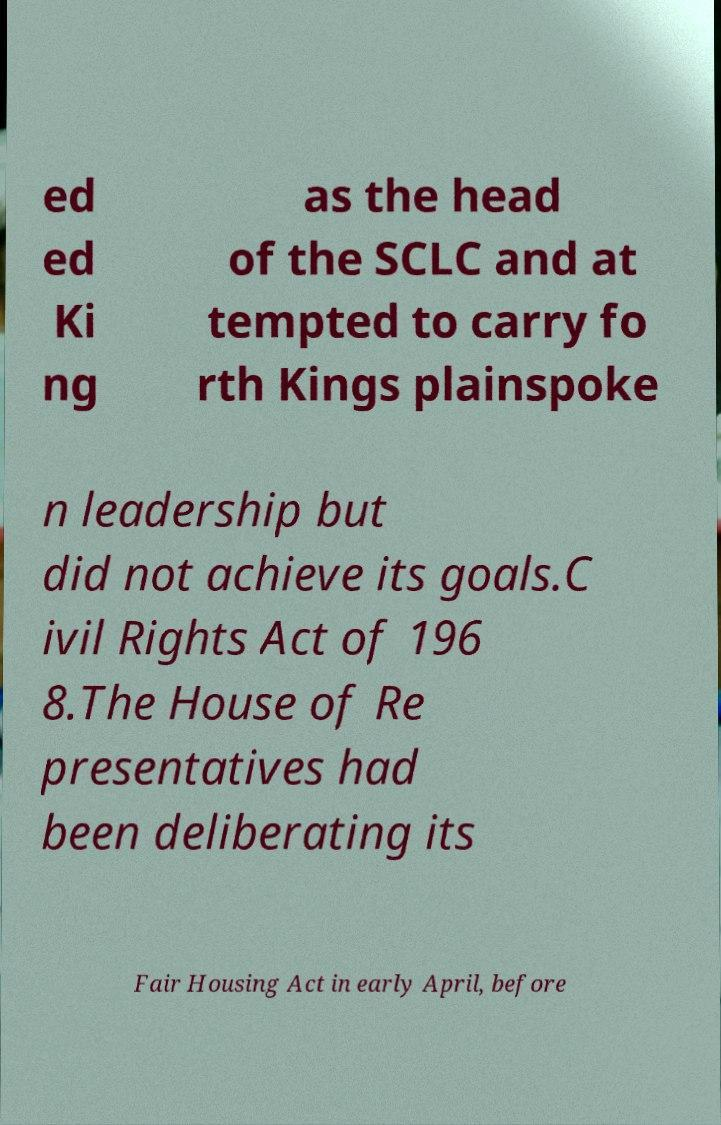Can you read and provide the text displayed in the image?This photo seems to have some interesting text. Can you extract and type it out for me? ed ed Ki ng as the head of the SCLC and at tempted to carry fo rth Kings plainspoke n leadership but did not achieve its goals.C ivil Rights Act of 196 8.The House of Re presentatives had been deliberating its Fair Housing Act in early April, before 